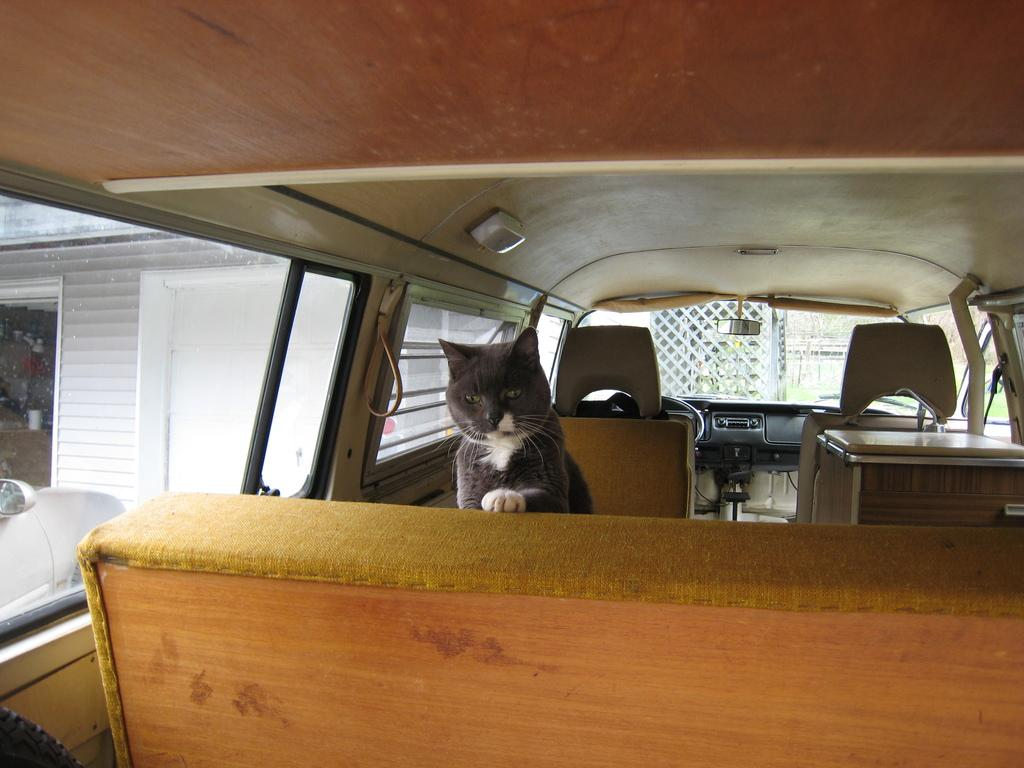What is the setting of the image? The image is taken inside a vehicle. What can be seen in the center of the image? There is a cat in the center of the image. What is visible through the window glass? There is a shed and a gate visible through the window glass. What type of drug is the cat taking in the image? There is no indication in the image that the cat is taking any drug, so it cannot be determined from the picture. 